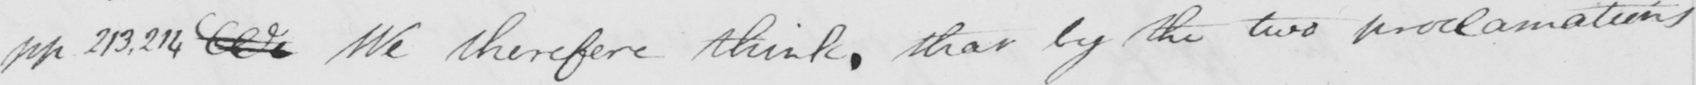Can you read and transcribe this handwriting? pp 213,214 We therefore think , that by the two proclamations 